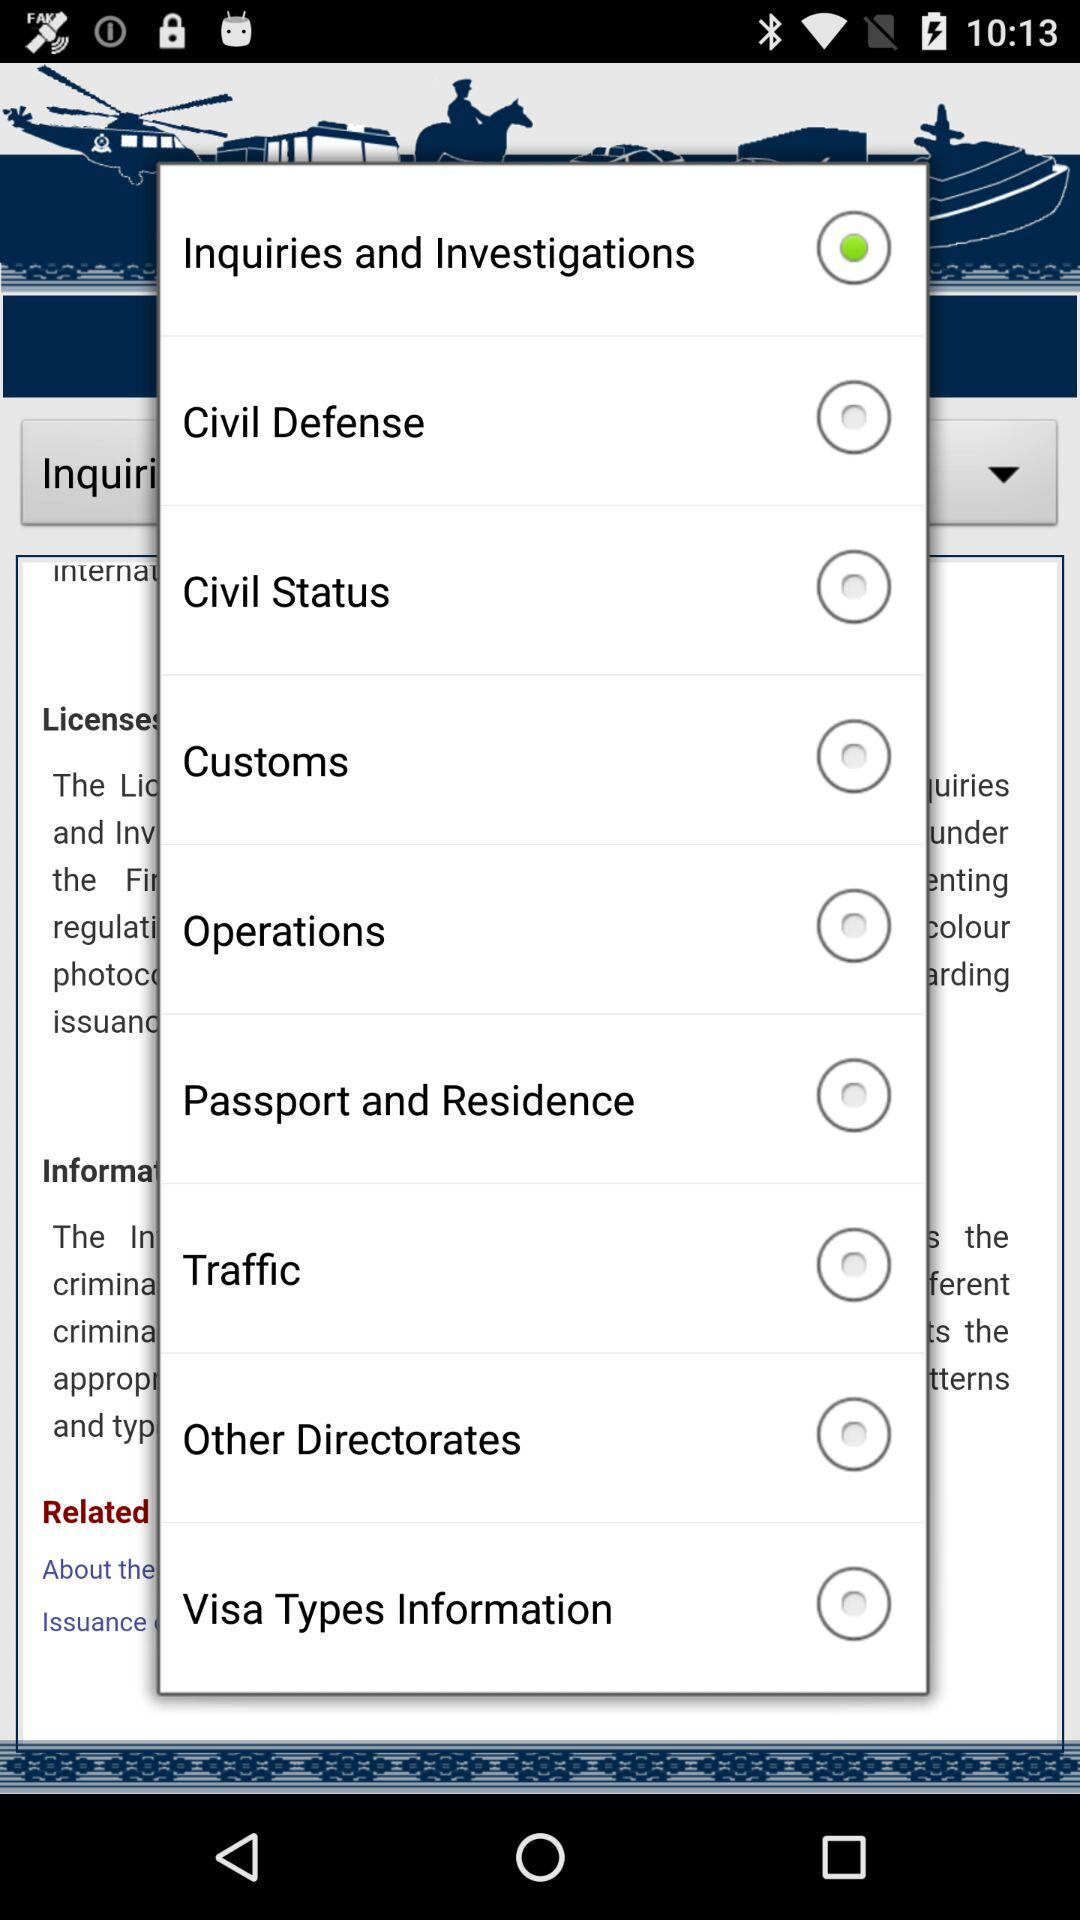Which option is selected? The selected option is "Inquiries and Investigations". 